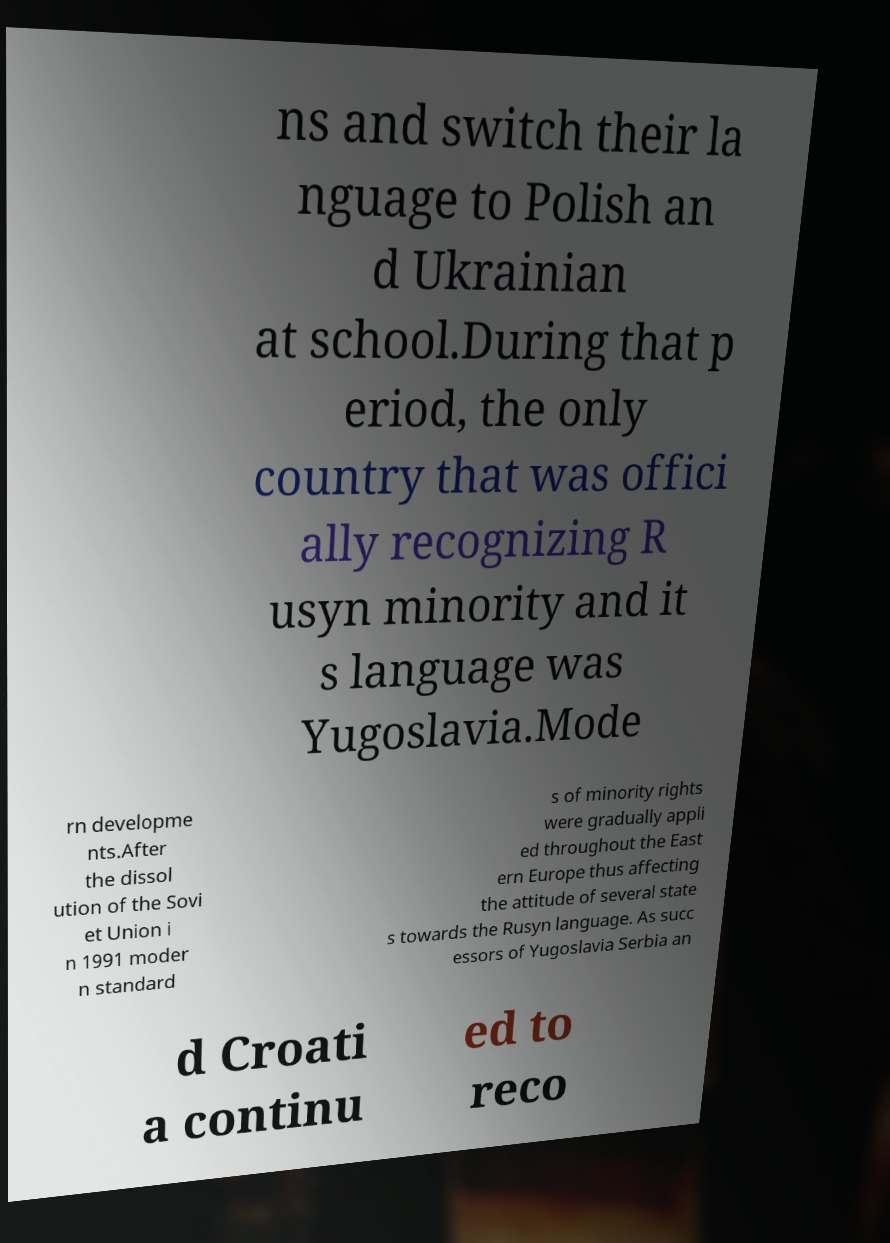I need the written content from this picture converted into text. Can you do that? ns and switch their la nguage to Polish an d Ukrainian at school.During that p eriod, the only country that was offici ally recognizing R usyn minority and it s language was Yugoslavia.Mode rn developme nts.After the dissol ution of the Sovi et Union i n 1991 moder n standard s of minority rights were gradually appli ed throughout the East ern Europe thus affecting the attitude of several state s towards the Rusyn language. As succ essors of Yugoslavia Serbia an d Croati a continu ed to reco 